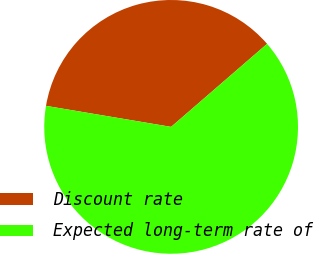<chart> <loc_0><loc_0><loc_500><loc_500><pie_chart><fcel>Discount rate<fcel>Expected long-term rate of<nl><fcel>36.0%<fcel>64.0%<nl></chart> 